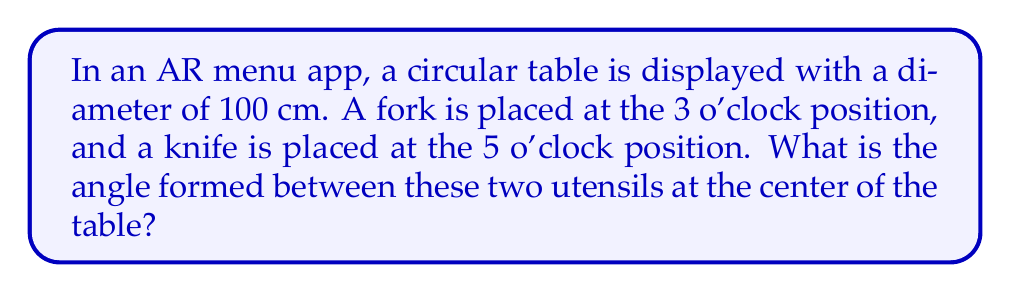Can you solve this math problem? Let's approach this step-by-step:

1) First, we need to understand that a circular table represents a full 360°.

2) The clock positions can be translated into angles:
   - 3 o'clock position is at 0° (or 360°)
   - 5 o'clock position is at $\frac{5}{12} \times 360° = 150°$

3) To find the angle between the utensils, we subtract the smaller angle from the larger:

   $$150° - 0° = 150°$$

4) However, we need to consider whether this is the smaller angle between the utensils. There are always two angles between two points on a circle, and we want the smaller one.

5) The other angle would be:

   $$360° - 150° = 210°$$

6) Since 150° is smaller than 210°, our original calculation was correct.

[asy]
unitsize(2cm);
draw(circle((0,0),1));
draw((0,0)--(1,0),Arrow);
draw((0,0)--(cos(150*pi/180),sin(150*pi/180)),Arrow);
label("Fork", (1.1,0));
label("Knife", (cos(150*pi/180),sin(150*pi/180)), NE);
draw(arc((0,0),0.7,0,150),Arrow);
label("150°", (0.5,0.3));
[/asy]
Answer: 150° 